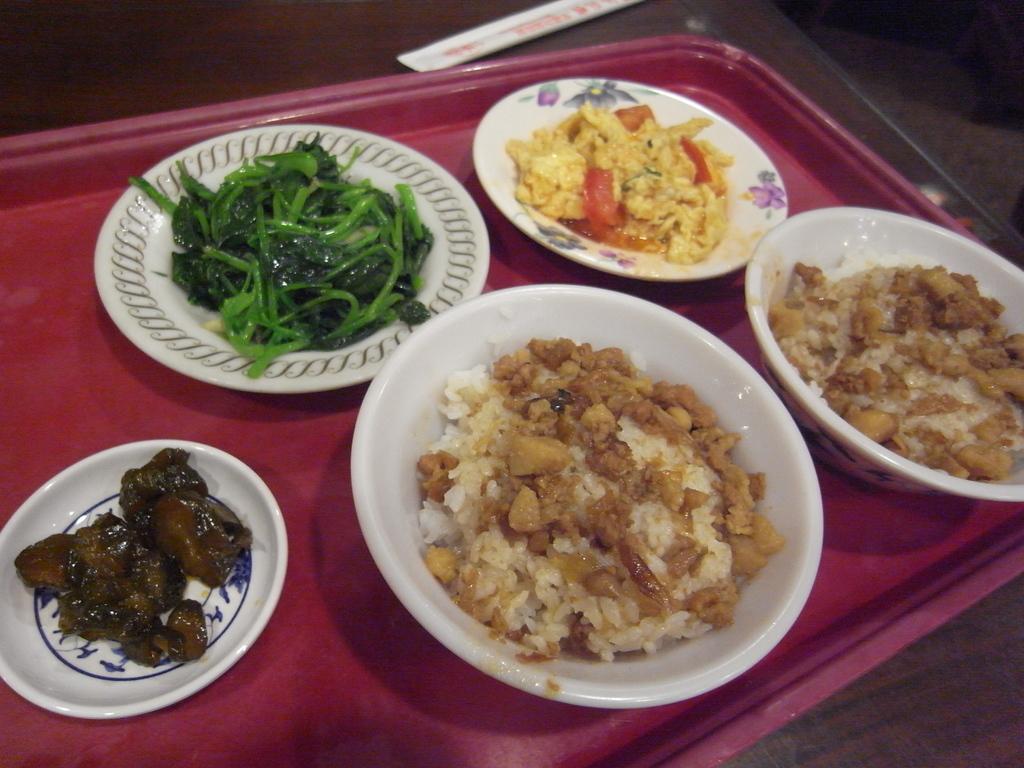Could you give a brief overview of what you see in this image? In this picture, we see three plates containing food items and two bowls containing food are placed on the pink color tray or a table. Beside that, we see an object in white color. In the background, it is white in color. 